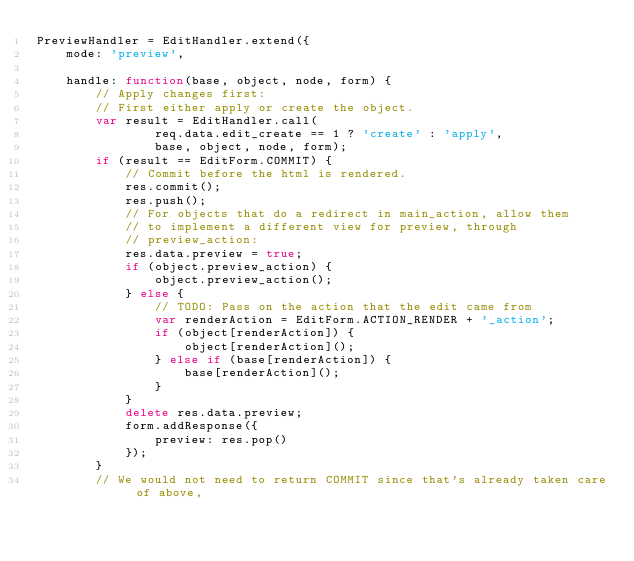Convert code to text. <code><loc_0><loc_0><loc_500><loc_500><_JavaScript_>PreviewHandler = EditHandler.extend({
	mode: 'preview',

	handle:	function(base, object, node, form) {
		// Apply changes first:
		// First either apply or create the object.
		var result = EditHandler.call(
				req.data.edit_create == 1 ? 'create' : 'apply',
				base, object, node, form);
		if (result == EditForm.COMMIT) {
			// Commit before the html is rendered.
			res.commit();
			res.push();
			// For objects that do a redirect in main_action, allow them
			// to implement a different view for preview, through
			// preview_action:
			res.data.preview = true;
			if (object.preview_action) {
				object.preview_action();
			} else {
				// TODO: Pass on the action that the edit came from
				var renderAction = EditForm.ACTION_RENDER + '_action';
				if (object[renderAction]) {
					object[renderAction]();
				} else if (base[renderAction]) {
					base[renderAction]();
				}
			}
			delete res.data.preview;
			form.addResponse({
				preview: res.pop()
			});
		}
		// We would not need to return COMMIT since that's already taken care of above,</code> 